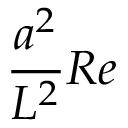<formula> <loc_0><loc_0><loc_500><loc_500>\frac { a ^ { 2 } } { L ^ { 2 } } R e</formula> 